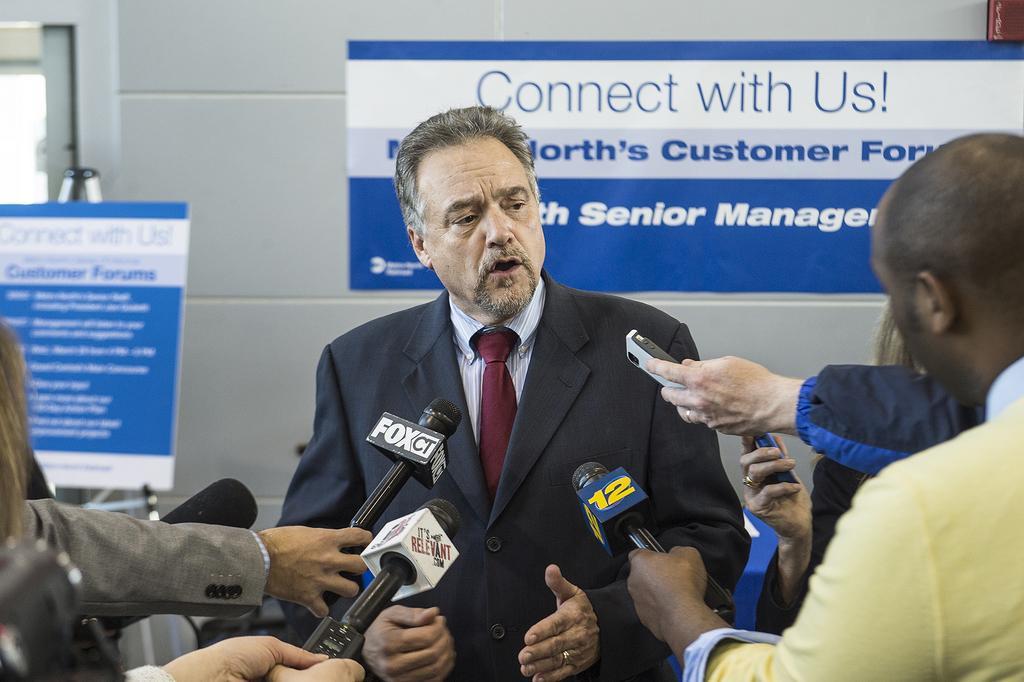In one or two sentences, can you explain what this image depicts? In this image there are persons standing. In the center there is a man standing and speaking. In front of the person there are mics. In the background there are banners with some text written on it. 